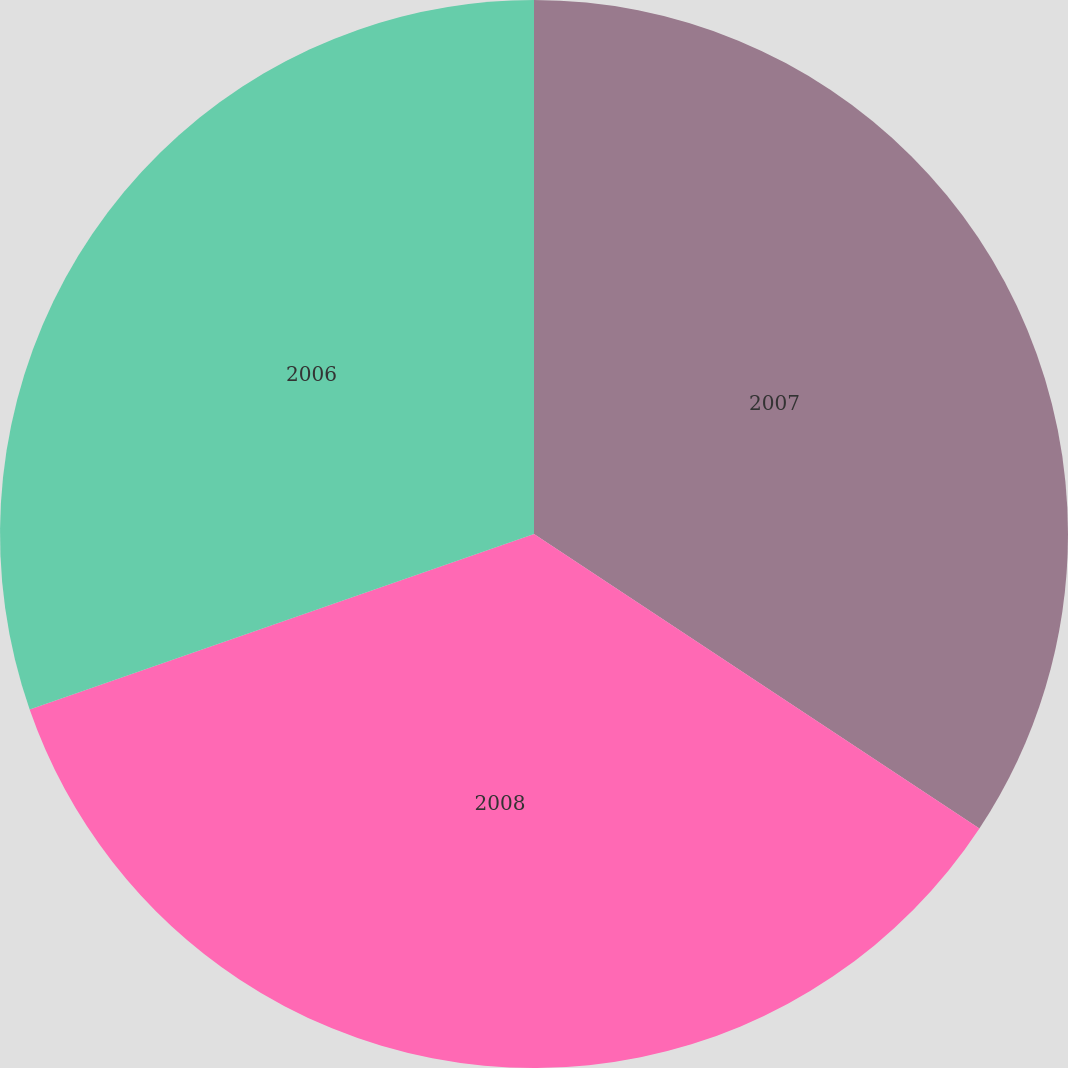<chart> <loc_0><loc_0><loc_500><loc_500><pie_chart><fcel>2007<fcel>2008<fcel>2006<nl><fcel>34.3%<fcel>35.37%<fcel>30.33%<nl></chart> 